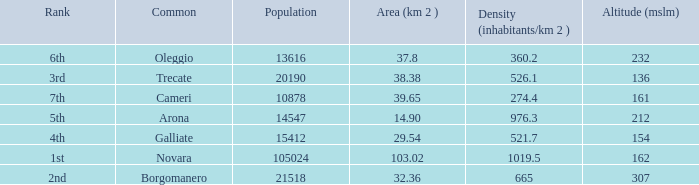Which common has an area (km2) of 38.38? Trecate. 